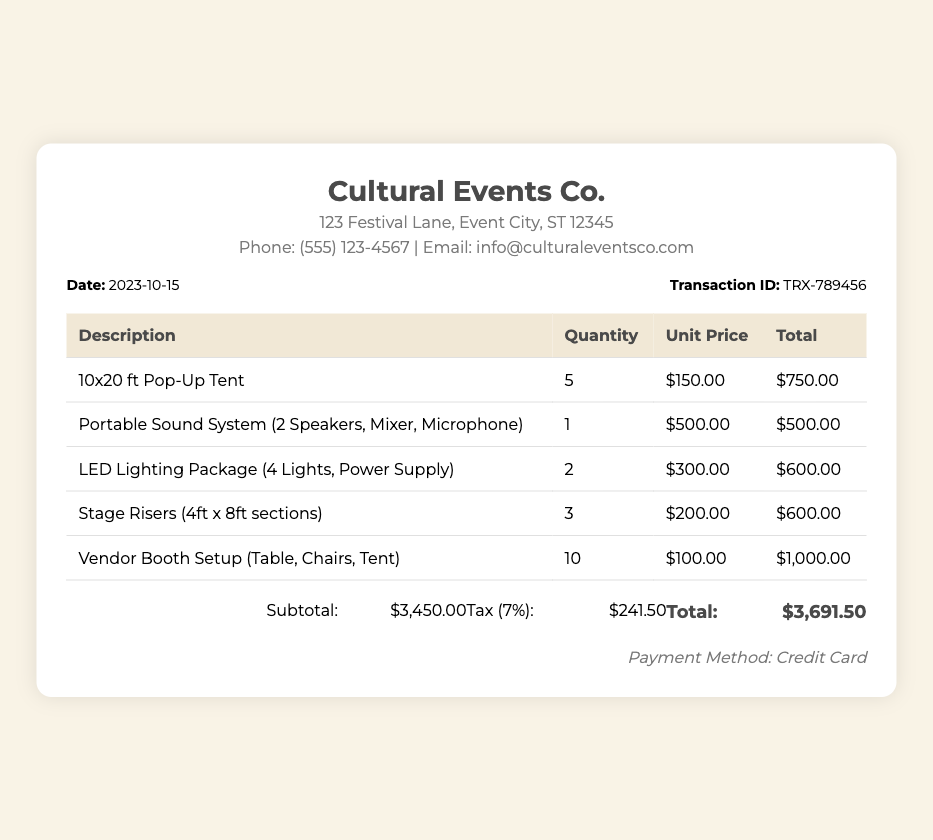What is the date of the transaction? The date of the transaction is explicitly mentioned in the document.
Answer: 2023-10-15 What is the transaction ID? The transaction ID is a unique identifier provided in the document for the transaction.
Answer: TRX-789456 How many 10x20 ft Pop-Up Tents were rented? The quantity of the 10x20 ft Pop-Up Tents is listed in the detail section of the receipt.
Answer: 5 What is the total amount charged for the Portable Sound System? The total amount for an individual item is noted in the table of the document.
Answer: $500.00 What is the subtotal before tax? The subtotal is calculated based on the total costs before applying tax, which is provided in the totals section.
Answer: $3,450.00 What is the tax percentage applied? The tax percentage is specified and is a common figure for transactions in such documents.
Answer: 7% What payment method was used? The payment method is indicated towards the end of the receipt.
Answer: Credit Card What is the total amount including tax? The total amount is the final amount after including tax, which is shown clearly in the totals section.
Answer: $3,691.50 How many items were rented in total? This is the sum of the quantities of different items rented as listed in the receipt.
Answer: 30 